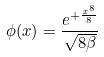Convert formula to latex. <formula><loc_0><loc_0><loc_500><loc_500>\phi ( x ) = \frac { e ^ { + \frac { x ^ { 8 } } { 8 } } } { \sqrt { 8 \beta } }</formula> 